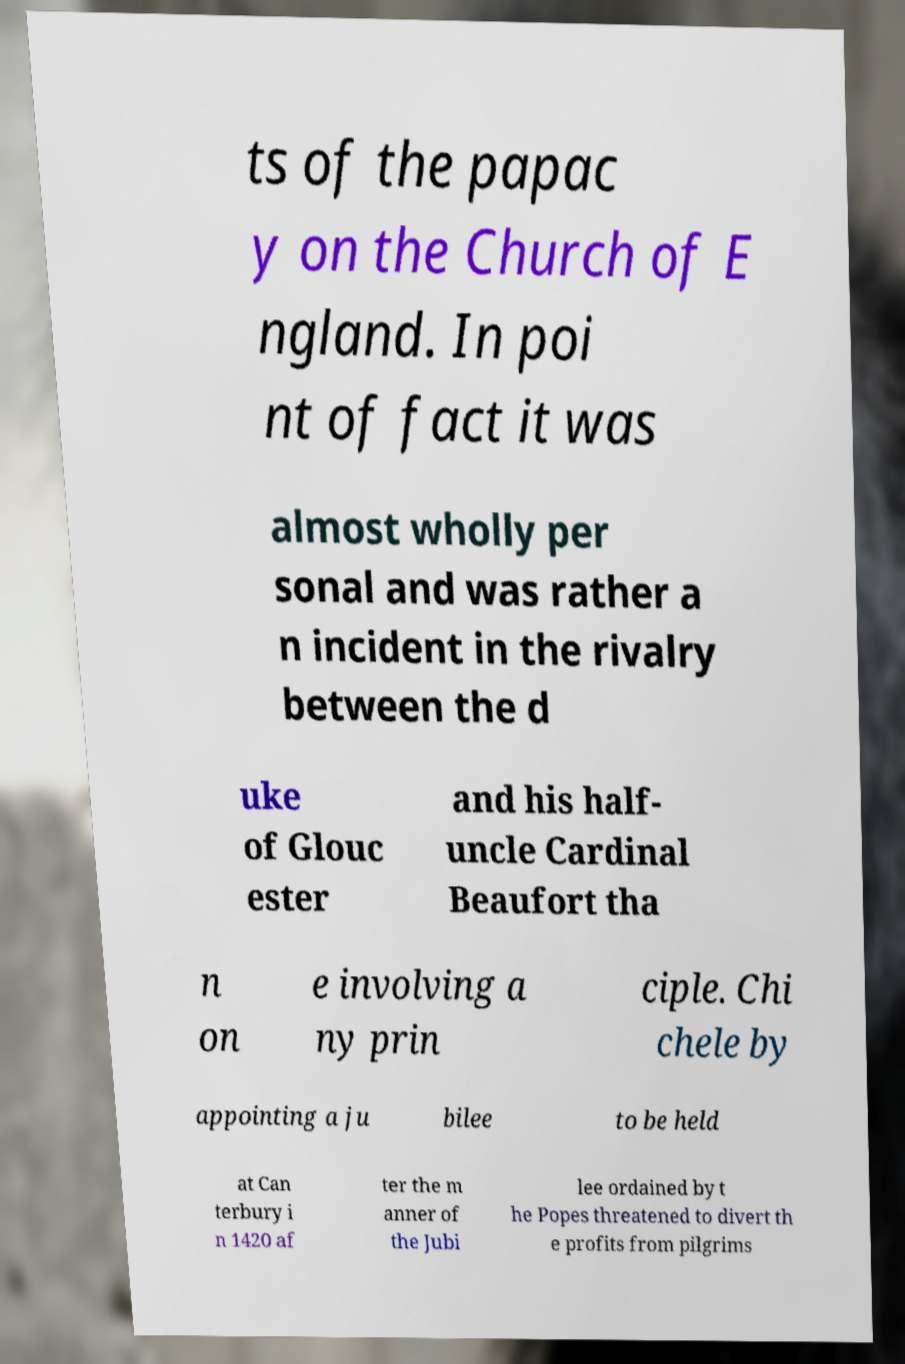There's text embedded in this image that I need extracted. Can you transcribe it verbatim? ts of the papac y on the Church of E ngland. In poi nt of fact it was almost wholly per sonal and was rather a n incident in the rivalry between the d uke of Glouc ester and his half- uncle Cardinal Beaufort tha n on e involving a ny prin ciple. Chi chele by appointing a ju bilee to be held at Can terbury i n 1420 af ter the m anner of the Jubi lee ordained by t he Popes threatened to divert th e profits from pilgrims 